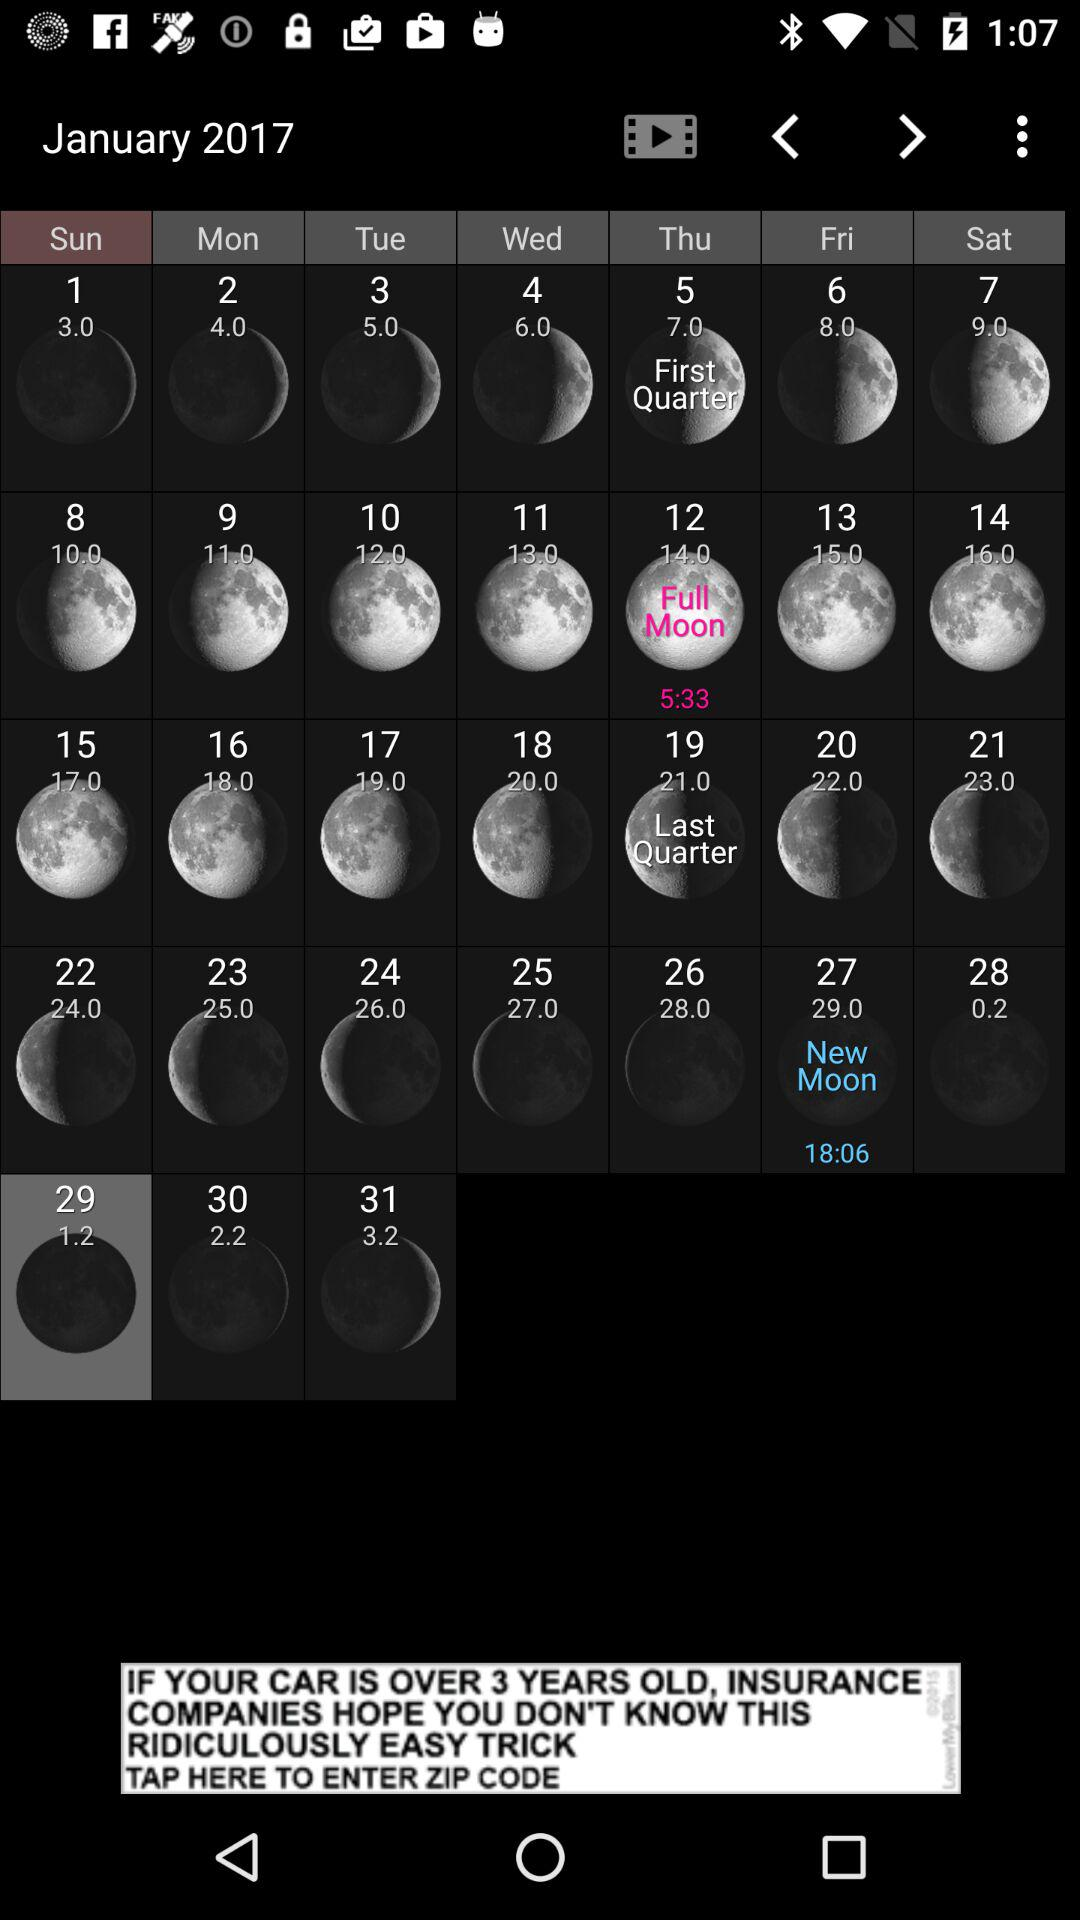What's the occurred time of the New Moon on January 27, 2017? The time is 18:06. 